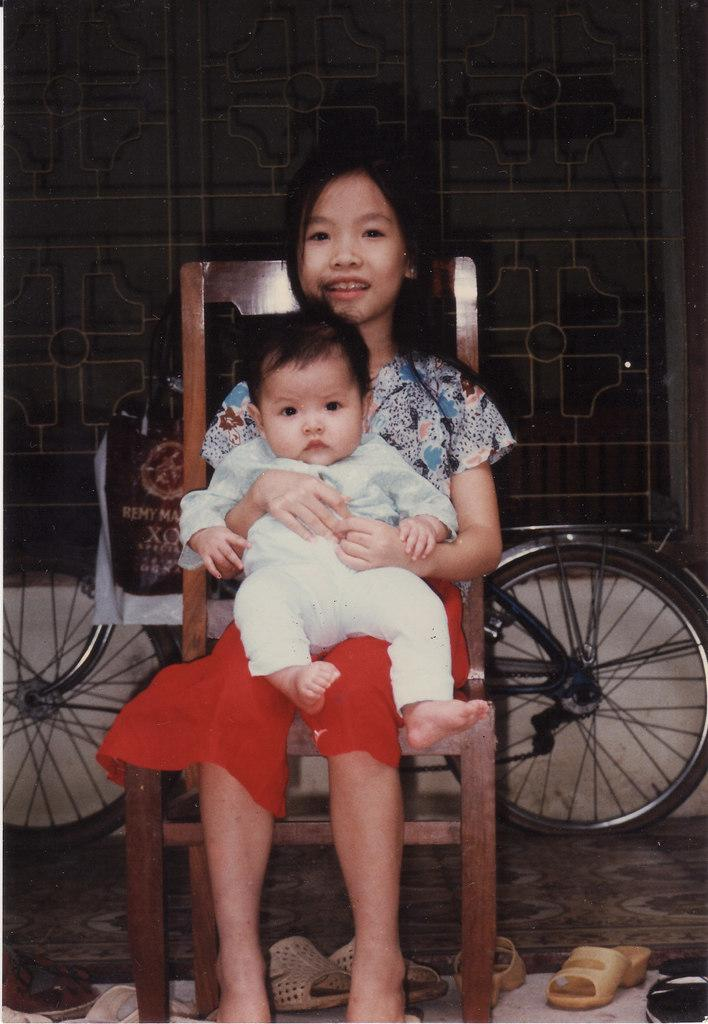What is the girl in the image sitting on? The girl is sitting on a wooden chair. Can you describe the position of the child in relation to the girl? There is a child above the girl. What can be seen in the background of the image? There is a bicycle with a bag in the background. Where is the bicycle located in relation to the window? The bicycle is in front of a window. What type of footwear is on the floor? There are chappals on the floor. What type of dinner is being served in the image? There is no dinner present in the image. Is the girl sitting in a hospital room in the image? There is no indication in the image that the girl is in a hospital room. 